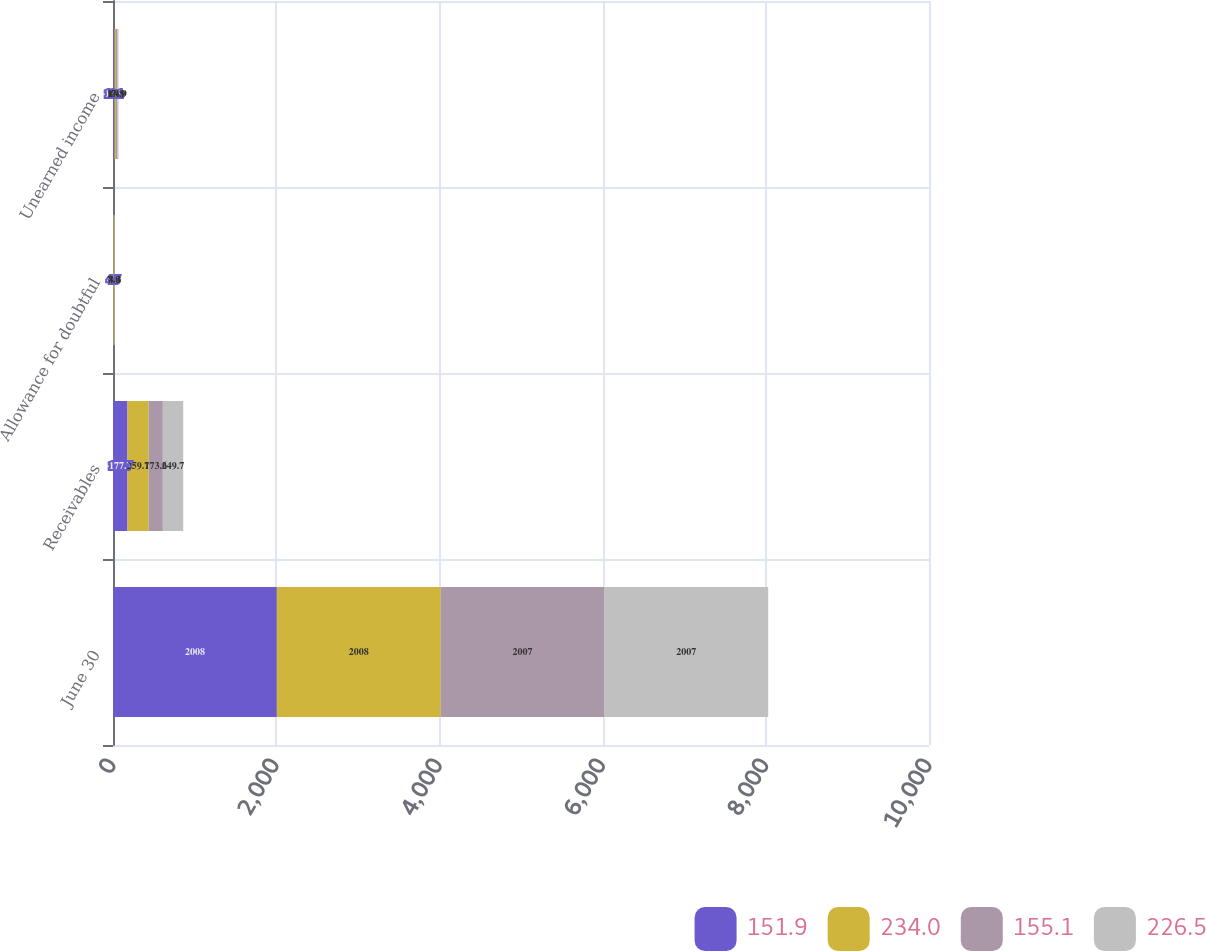<chart> <loc_0><loc_0><loc_500><loc_500><stacked_bar_chart><ecel><fcel>June 30<fcel>Receivables<fcel>Allowance for doubtful<fcel>Unearned income<nl><fcel>151.9<fcel>2008<fcel>177.7<fcel>4.5<fcel>18.1<nl><fcel>234<fcel>2008<fcel>259.7<fcel>7.9<fcel>17.8<nl><fcel>155.1<fcel>2007<fcel>173.6<fcel>4.8<fcel>16.9<nl><fcel>226.5<fcel>2007<fcel>249.7<fcel>8.3<fcel>14.9<nl></chart> 